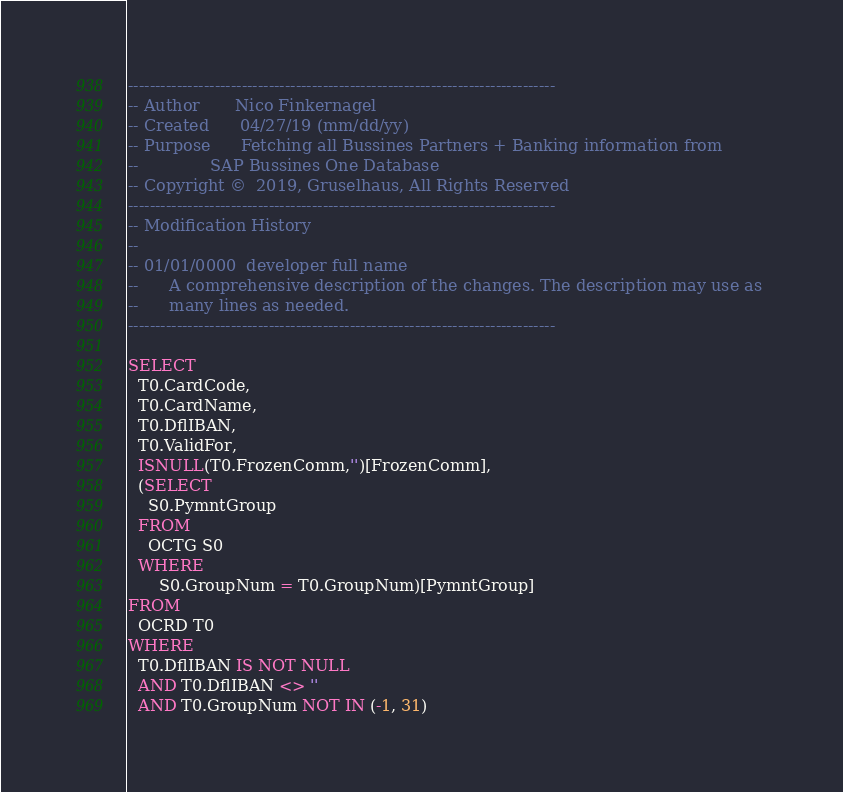Convert code to text. <code><loc_0><loc_0><loc_500><loc_500><_SQL_>-------------------------------------------------------------------------------
-- Author       Nico Finkernagel
-- Created      04/27/19 (mm/dd/yy)
-- Purpose      Fetching all Bussines Partners + Banking information from 
--              SAP Bussines One Database
-- Copyright ©  2019, Gruselhaus, All Rights Reserved
-------------------------------------------------------------------------------
-- Modification History
--
-- 01/01/0000  developer full name  
--      A comprehensive description of the changes. The description may use as 
--      many lines as needed.
-------------------------------------------------------------------------------

SELECT
  T0.CardCode,
  T0.CardName,
  T0.DflIBAN,
  T0.ValidFor,
  ISNULL(T0.FrozenComm,'')[FrozenComm],
  (SELECT
    S0.PymntGroup
  FROM
    OCTG S0
  WHERE 
      S0.GroupNum = T0.GroupNum)[PymntGroup]
FROM
  OCRD T0
WHERE 
  T0.DflIBAN IS NOT NULL
  AND T0.DflIBAN <> ''
  AND T0.GroupNum NOT IN (-1, 31)</code> 